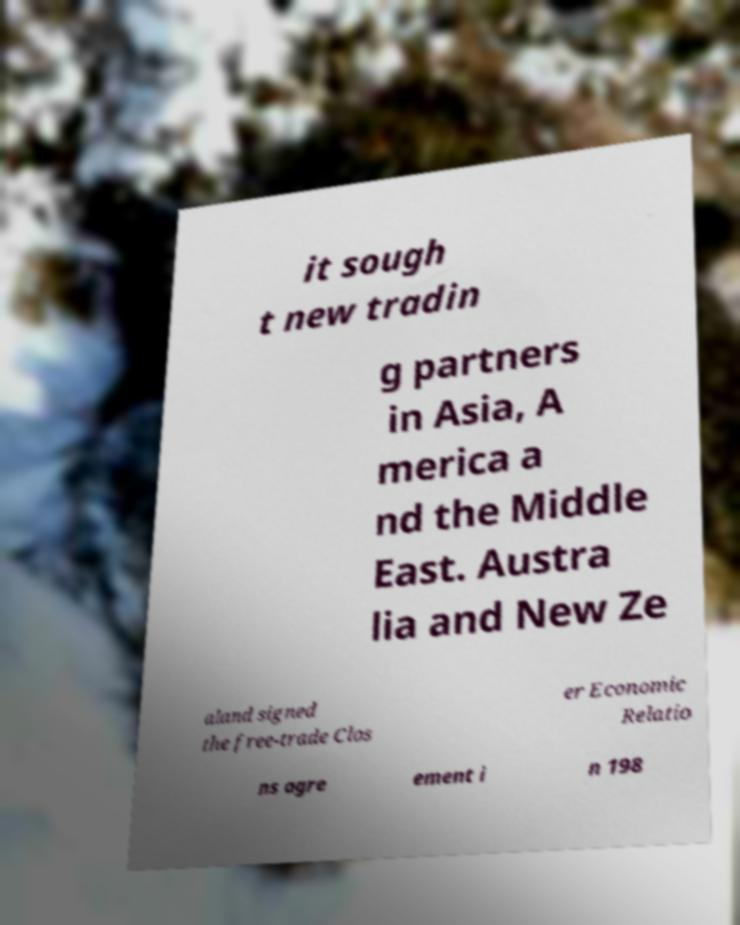Please read and relay the text visible in this image. What does it say? it sough t new tradin g partners in Asia, A merica a nd the Middle East. Austra lia and New Ze aland signed the free-trade Clos er Economic Relatio ns agre ement i n 198 